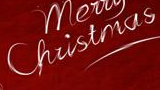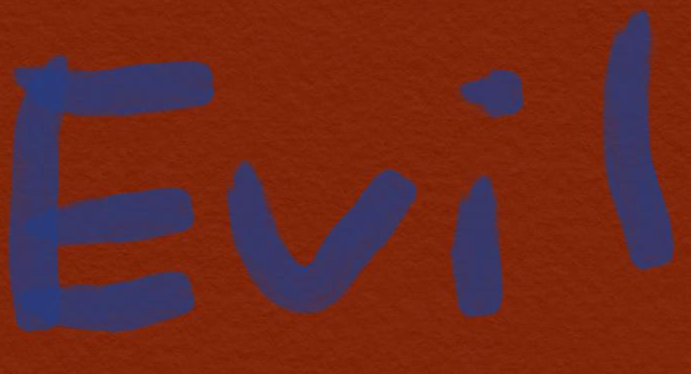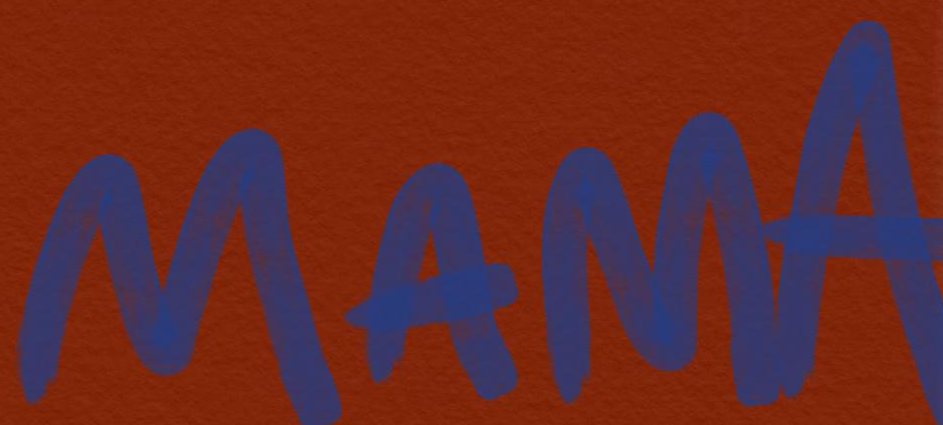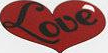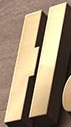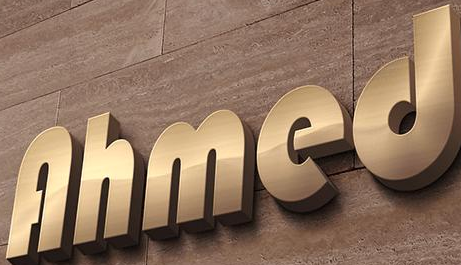What words can you see in these images in sequence, separated by a semicolon? Christmas; Evil; MAMA; Love; H; Ahmed 